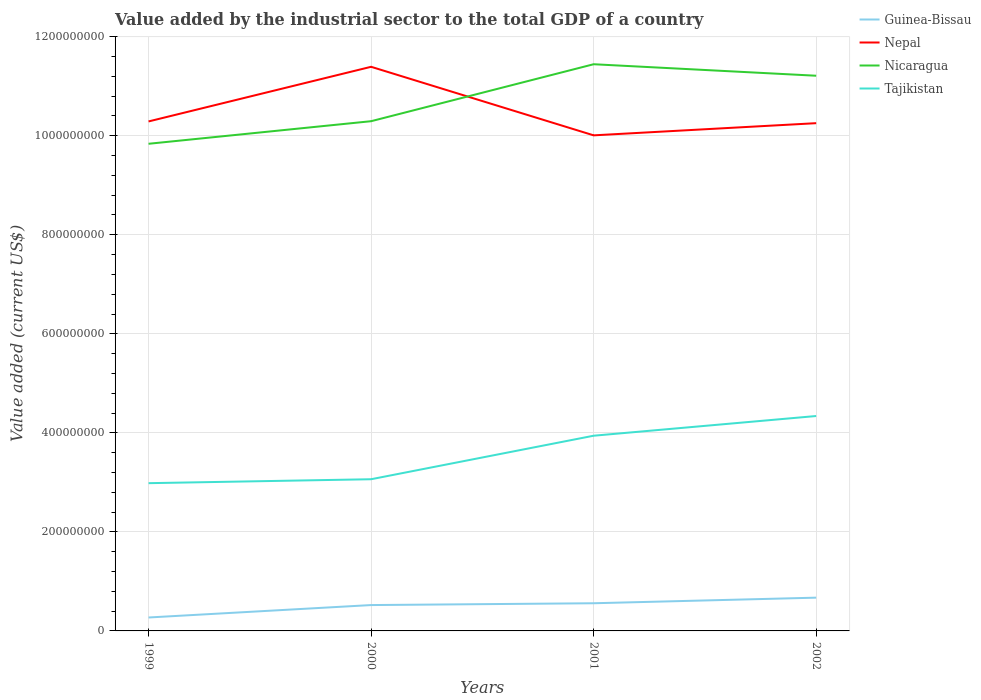How many different coloured lines are there?
Your response must be concise. 4. Does the line corresponding to Nepal intersect with the line corresponding to Nicaragua?
Offer a very short reply. Yes. Is the number of lines equal to the number of legend labels?
Provide a short and direct response. Yes. Across all years, what is the maximum value added by the industrial sector to the total GDP in Nicaragua?
Offer a terse response. 9.84e+08. In which year was the value added by the industrial sector to the total GDP in Tajikistan maximum?
Offer a terse response. 1999. What is the total value added by the industrial sector to the total GDP in Tajikistan in the graph?
Your response must be concise. -3.98e+07. What is the difference between the highest and the second highest value added by the industrial sector to the total GDP in Nepal?
Offer a terse response. 1.38e+08. What is the difference between the highest and the lowest value added by the industrial sector to the total GDP in Nicaragua?
Your answer should be very brief. 2. Is the value added by the industrial sector to the total GDP in Tajikistan strictly greater than the value added by the industrial sector to the total GDP in Nicaragua over the years?
Ensure brevity in your answer.  Yes. How many lines are there?
Keep it short and to the point. 4. How many years are there in the graph?
Offer a terse response. 4. Are the values on the major ticks of Y-axis written in scientific E-notation?
Give a very brief answer. No. Does the graph contain grids?
Offer a terse response. Yes. How many legend labels are there?
Provide a short and direct response. 4. What is the title of the graph?
Your response must be concise. Value added by the industrial sector to the total GDP of a country. What is the label or title of the Y-axis?
Your answer should be very brief. Value added (current US$). What is the Value added (current US$) of Guinea-Bissau in 1999?
Ensure brevity in your answer.  2.71e+07. What is the Value added (current US$) of Nepal in 1999?
Make the answer very short. 1.03e+09. What is the Value added (current US$) in Nicaragua in 1999?
Offer a very short reply. 9.84e+08. What is the Value added (current US$) in Tajikistan in 1999?
Make the answer very short. 2.98e+08. What is the Value added (current US$) of Guinea-Bissau in 2000?
Provide a short and direct response. 5.22e+07. What is the Value added (current US$) in Nepal in 2000?
Offer a very short reply. 1.14e+09. What is the Value added (current US$) of Nicaragua in 2000?
Your answer should be very brief. 1.03e+09. What is the Value added (current US$) in Tajikistan in 2000?
Offer a terse response. 3.06e+08. What is the Value added (current US$) of Guinea-Bissau in 2001?
Offer a very short reply. 5.59e+07. What is the Value added (current US$) in Nepal in 2001?
Give a very brief answer. 1.00e+09. What is the Value added (current US$) of Nicaragua in 2001?
Ensure brevity in your answer.  1.14e+09. What is the Value added (current US$) of Tajikistan in 2001?
Keep it short and to the point. 3.94e+08. What is the Value added (current US$) of Guinea-Bissau in 2002?
Your response must be concise. 6.72e+07. What is the Value added (current US$) of Nepal in 2002?
Provide a short and direct response. 1.03e+09. What is the Value added (current US$) in Nicaragua in 2002?
Make the answer very short. 1.12e+09. What is the Value added (current US$) in Tajikistan in 2002?
Offer a very short reply. 4.34e+08. Across all years, what is the maximum Value added (current US$) in Guinea-Bissau?
Keep it short and to the point. 6.72e+07. Across all years, what is the maximum Value added (current US$) of Nepal?
Give a very brief answer. 1.14e+09. Across all years, what is the maximum Value added (current US$) in Nicaragua?
Make the answer very short. 1.14e+09. Across all years, what is the maximum Value added (current US$) of Tajikistan?
Offer a terse response. 4.34e+08. Across all years, what is the minimum Value added (current US$) in Guinea-Bissau?
Your answer should be compact. 2.71e+07. Across all years, what is the minimum Value added (current US$) in Nepal?
Make the answer very short. 1.00e+09. Across all years, what is the minimum Value added (current US$) in Nicaragua?
Offer a terse response. 9.84e+08. Across all years, what is the minimum Value added (current US$) in Tajikistan?
Give a very brief answer. 2.98e+08. What is the total Value added (current US$) of Guinea-Bissau in the graph?
Your answer should be compact. 2.02e+08. What is the total Value added (current US$) of Nepal in the graph?
Your answer should be compact. 4.19e+09. What is the total Value added (current US$) in Nicaragua in the graph?
Offer a very short reply. 4.28e+09. What is the total Value added (current US$) in Tajikistan in the graph?
Your answer should be compact. 1.43e+09. What is the difference between the Value added (current US$) of Guinea-Bissau in 1999 and that in 2000?
Offer a very short reply. -2.51e+07. What is the difference between the Value added (current US$) in Nepal in 1999 and that in 2000?
Provide a succinct answer. -1.10e+08. What is the difference between the Value added (current US$) of Nicaragua in 1999 and that in 2000?
Offer a terse response. -4.56e+07. What is the difference between the Value added (current US$) in Tajikistan in 1999 and that in 2000?
Offer a terse response. -7.97e+06. What is the difference between the Value added (current US$) of Guinea-Bissau in 1999 and that in 2001?
Keep it short and to the point. -2.88e+07. What is the difference between the Value added (current US$) in Nepal in 1999 and that in 2001?
Ensure brevity in your answer.  2.81e+07. What is the difference between the Value added (current US$) of Nicaragua in 1999 and that in 2001?
Keep it short and to the point. -1.61e+08. What is the difference between the Value added (current US$) of Tajikistan in 1999 and that in 2001?
Keep it short and to the point. -9.58e+07. What is the difference between the Value added (current US$) of Guinea-Bissau in 1999 and that in 2002?
Your answer should be very brief. -4.01e+07. What is the difference between the Value added (current US$) in Nepal in 1999 and that in 2002?
Provide a succinct answer. 3.50e+06. What is the difference between the Value added (current US$) in Nicaragua in 1999 and that in 2002?
Make the answer very short. -1.37e+08. What is the difference between the Value added (current US$) of Tajikistan in 1999 and that in 2002?
Keep it short and to the point. -1.36e+08. What is the difference between the Value added (current US$) in Guinea-Bissau in 2000 and that in 2001?
Provide a short and direct response. -3.66e+06. What is the difference between the Value added (current US$) of Nepal in 2000 and that in 2001?
Offer a very short reply. 1.38e+08. What is the difference between the Value added (current US$) of Nicaragua in 2000 and that in 2001?
Provide a short and direct response. -1.15e+08. What is the difference between the Value added (current US$) of Tajikistan in 2000 and that in 2001?
Your answer should be compact. -8.79e+07. What is the difference between the Value added (current US$) of Guinea-Bissau in 2000 and that in 2002?
Provide a succinct answer. -1.50e+07. What is the difference between the Value added (current US$) of Nepal in 2000 and that in 2002?
Your answer should be very brief. 1.14e+08. What is the difference between the Value added (current US$) of Nicaragua in 2000 and that in 2002?
Offer a terse response. -9.18e+07. What is the difference between the Value added (current US$) in Tajikistan in 2000 and that in 2002?
Keep it short and to the point. -1.28e+08. What is the difference between the Value added (current US$) of Guinea-Bissau in 2001 and that in 2002?
Ensure brevity in your answer.  -1.13e+07. What is the difference between the Value added (current US$) of Nepal in 2001 and that in 2002?
Keep it short and to the point. -2.46e+07. What is the difference between the Value added (current US$) in Nicaragua in 2001 and that in 2002?
Your answer should be very brief. 2.32e+07. What is the difference between the Value added (current US$) in Tajikistan in 2001 and that in 2002?
Provide a short and direct response. -3.98e+07. What is the difference between the Value added (current US$) of Guinea-Bissau in 1999 and the Value added (current US$) of Nepal in 2000?
Offer a very short reply. -1.11e+09. What is the difference between the Value added (current US$) in Guinea-Bissau in 1999 and the Value added (current US$) in Nicaragua in 2000?
Your answer should be compact. -1.00e+09. What is the difference between the Value added (current US$) in Guinea-Bissau in 1999 and the Value added (current US$) in Tajikistan in 2000?
Offer a very short reply. -2.79e+08. What is the difference between the Value added (current US$) in Nepal in 1999 and the Value added (current US$) in Nicaragua in 2000?
Give a very brief answer. -4.66e+05. What is the difference between the Value added (current US$) in Nepal in 1999 and the Value added (current US$) in Tajikistan in 2000?
Your answer should be compact. 7.23e+08. What is the difference between the Value added (current US$) of Nicaragua in 1999 and the Value added (current US$) of Tajikistan in 2000?
Keep it short and to the point. 6.77e+08. What is the difference between the Value added (current US$) of Guinea-Bissau in 1999 and the Value added (current US$) of Nepal in 2001?
Give a very brief answer. -9.74e+08. What is the difference between the Value added (current US$) in Guinea-Bissau in 1999 and the Value added (current US$) in Nicaragua in 2001?
Ensure brevity in your answer.  -1.12e+09. What is the difference between the Value added (current US$) of Guinea-Bissau in 1999 and the Value added (current US$) of Tajikistan in 2001?
Your response must be concise. -3.67e+08. What is the difference between the Value added (current US$) of Nepal in 1999 and the Value added (current US$) of Nicaragua in 2001?
Give a very brief answer. -1.16e+08. What is the difference between the Value added (current US$) in Nepal in 1999 and the Value added (current US$) in Tajikistan in 2001?
Your answer should be very brief. 6.35e+08. What is the difference between the Value added (current US$) of Nicaragua in 1999 and the Value added (current US$) of Tajikistan in 2001?
Ensure brevity in your answer.  5.90e+08. What is the difference between the Value added (current US$) of Guinea-Bissau in 1999 and the Value added (current US$) of Nepal in 2002?
Offer a terse response. -9.98e+08. What is the difference between the Value added (current US$) of Guinea-Bissau in 1999 and the Value added (current US$) of Nicaragua in 2002?
Keep it short and to the point. -1.09e+09. What is the difference between the Value added (current US$) in Guinea-Bissau in 1999 and the Value added (current US$) in Tajikistan in 2002?
Your answer should be compact. -4.07e+08. What is the difference between the Value added (current US$) of Nepal in 1999 and the Value added (current US$) of Nicaragua in 2002?
Give a very brief answer. -9.23e+07. What is the difference between the Value added (current US$) of Nepal in 1999 and the Value added (current US$) of Tajikistan in 2002?
Your answer should be very brief. 5.95e+08. What is the difference between the Value added (current US$) of Nicaragua in 1999 and the Value added (current US$) of Tajikistan in 2002?
Offer a terse response. 5.50e+08. What is the difference between the Value added (current US$) of Guinea-Bissau in 2000 and the Value added (current US$) of Nepal in 2001?
Offer a terse response. -9.49e+08. What is the difference between the Value added (current US$) of Guinea-Bissau in 2000 and the Value added (current US$) of Nicaragua in 2001?
Your response must be concise. -1.09e+09. What is the difference between the Value added (current US$) in Guinea-Bissau in 2000 and the Value added (current US$) in Tajikistan in 2001?
Make the answer very short. -3.42e+08. What is the difference between the Value added (current US$) in Nepal in 2000 and the Value added (current US$) in Nicaragua in 2001?
Keep it short and to the point. -5.18e+06. What is the difference between the Value added (current US$) of Nepal in 2000 and the Value added (current US$) of Tajikistan in 2001?
Ensure brevity in your answer.  7.45e+08. What is the difference between the Value added (current US$) in Nicaragua in 2000 and the Value added (current US$) in Tajikistan in 2001?
Your answer should be very brief. 6.35e+08. What is the difference between the Value added (current US$) of Guinea-Bissau in 2000 and the Value added (current US$) of Nepal in 2002?
Keep it short and to the point. -9.73e+08. What is the difference between the Value added (current US$) of Guinea-Bissau in 2000 and the Value added (current US$) of Nicaragua in 2002?
Your answer should be very brief. -1.07e+09. What is the difference between the Value added (current US$) of Guinea-Bissau in 2000 and the Value added (current US$) of Tajikistan in 2002?
Keep it short and to the point. -3.82e+08. What is the difference between the Value added (current US$) in Nepal in 2000 and the Value added (current US$) in Nicaragua in 2002?
Keep it short and to the point. 1.80e+07. What is the difference between the Value added (current US$) in Nepal in 2000 and the Value added (current US$) in Tajikistan in 2002?
Provide a short and direct response. 7.05e+08. What is the difference between the Value added (current US$) of Nicaragua in 2000 and the Value added (current US$) of Tajikistan in 2002?
Your answer should be compact. 5.95e+08. What is the difference between the Value added (current US$) of Guinea-Bissau in 2001 and the Value added (current US$) of Nepal in 2002?
Offer a terse response. -9.70e+08. What is the difference between the Value added (current US$) of Guinea-Bissau in 2001 and the Value added (current US$) of Nicaragua in 2002?
Give a very brief answer. -1.07e+09. What is the difference between the Value added (current US$) of Guinea-Bissau in 2001 and the Value added (current US$) of Tajikistan in 2002?
Provide a short and direct response. -3.78e+08. What is the difference between the Value added (current US$) in Nepal in 2001 and the Value added (current US$) in Nicaragua in 2002?
Give a very brief answer. -1.20e+08. What is the difference between the Value added (current US$) in Nepal in 2001 and the Value added (current US$) in Tajikistan in 2002?
Provide a short and direct response. 5.67e+08. What is the difference between the Value added (current US$) in Nicaragua in 2001 and the Value added (current US$) in Tajikistan in 2002?
Offer a terse response. 7.10e+08. What is the average Value added (current US$) of Guinea-Bissau per year?
Provide a short and direct response. 5.06e+07. What is the average Value added (current US$) in Nepal per year?
Make the answer very short. 1.05e+09. What is the average Value added (current US$) of Nicaragua per year?
Your answer should be very brief. 1.07e+09. What is the average Value added (current US$) of Tajikistan per year?
Make the answer very short. 3.58e+08. In the year 1999, what is the difference between the Value added (current US$) in Guinea-Bissau and Value added (current US$) in Nepal?
Ensure brevity in your answer.  -1.00e+09. In the year 1999, what is the difference between the Value added (current US$) in Guinea-Bissau and Value added (current US$) in Nicaragua?
Offer a terse response. -9.57e+08. In the year 1999, what is the difference between the Value added (current US$) in Guinea-Bissau and Value added (current US$) in Tajikistan?
Provide a short and direct response. -2.71e+08. In the year 1999, what is the difference between the Value added (current US$) in Nepal and Value added (current US$) in Nicaragua?
Provide a short and direct response. 4.51e+07. In the year 1999, what is the difference between the Value added (current US$) in Nepal and Value added (current US$) in Tajikistan?
Give a very brief answer. 7.31e+08. In the year 1999, what is the difference between the Value added (current US$) of Nicaragua and Value added (current US$) of Tajikistan?
Provide a succinct answer. 6.85e+08. In the year 2000, what is the difference between the Value added (current US$) of Guinea-Bissau and Value added (current US$) of Nepal?
Offer a very short reply. -1.09e+09. In the year 2000, what is the difference between the Value added (current US$) of Guinea-Bissau and Value added (current US$) of Nicaragua?
Your answer should be very brief. -9.77e+08. In the year 2000, what is the difference between the Value added (current US$) in Guinea-Bissau and Value added (current US$) in Tajikistan?
Offer a very short reply. -2.54e+08. In the year 2000, what is the difference between the Value added (current US$) in Nepal and Value added (current US$) in Nicaragua?
Give a very brief answer. 1.10e+08. In the year 2000, what is the difference between the Value added (current US$) of Nepal and Value added (current US$) of Tajikistan?
Provide a short and direct response. 8.33e+08. In the year 2000, what is the difference between the Value added (current US$) of Nicaragua and Value added (current US$) of Tajikistan?
Keep it short and to the point. 7.23e+08. In the year 2001, what is the difference between the Value added (current US$) in Guinea-Bissau and Value added (current US$) in Nepal?
Provide a short and direct response. -9.45e+08. In the year 2001, what is the difference between the Value added (current US$) in Guinea-Bissau and Value added (current US$) in Nicaragua?
Provide a short and direct response. -1.09e+09. In the year 2001, what is the difference between the Value added (current US$) of Guinea-Bissau and Value added (current US$) of Tajikistan?
Keep it short and to the point. -3.38e+08. In the year 2001, what is the difference between the Value added (current US$) in Nepal and Value added (current US$) in Nicaragua?
Make the answer very short. -1.44e+08. In the year 2001, what is the difference between the Value added (current US$) in Nepal and Value added (current US$) in Tajikistan?
Give a very brief answer. 6.07e+08. In the year 2001, what is the difference between the Value added (current US$) of Nicaragua and Value added (current US$) of Tajikistan?
Ensure brevity in your answer.  7.50e+08. In the year 2002, what is the difference between the Value added (current US$) in Guinea-Bissau and Value added (current US$) in Nepal?
Offer a very short reply. -9.58e+08. In the year 2002, what is the difference between the Value added (current US$) in Guinea-Bissau and Value added (current US$) in Nicaragua?
Give a very brief answer. -1.05e+09. In the year 2002, what is the difference between the Value added (current US$) of Guinea-Bissau and Value added (current US$) of Tajikistan?
Offer a very short reply. -3.67e+08. In the year 2002, what is the difference between the Value added (current US$) of Nepal and Value added (current US$) of Nicaragua?
Ensure brevity in your answer.  -9.58e+07. In the year 2002, what is the difference between the Value added (current US$) in Nepal and Value added (current US$) in Tajikistan?
Make the answer very short. 5.91e+08. In the year 2002, what is the difference between the Value added (current US$) in Nicaragua and Value added (current US$) in Tajikistan?
Your response must be concise. 6.87e+08. What is the ratio of the Value added (current US$) of Guinea-Bissau in 1999 to that in 2000?
Your answer should be compact. 0.52. What is the ratio of the Value added (current US$) in Nepal in 1999 to that in 2000?
Your answer should be compact. 0.9. What is the ratio of the Value added (current US$) of Nicaragua in 1999 to that in 2000?
Offer a very short reply. 0.96. What is the ratio of the Value added (current US$) of Tajikistan in 1999 to that in 2000?
Your response must be concise. 0.97. What is the ratio of the Value added (current US$) in Guinea-Bissau in 1999 to that in 2001?
Keep it short and to the point. 0.49. What is the ratio of the Value added (current US$) in Nepal in 1999 to that in 2001?
Offer a very short reply. 1.03. What is the ratio of the Value added (current US$) in Nicaragua in 1999 to that in 2001?
Make the answer very short. 0.86. What is the ratio of the Value added (current US$) in Tajikistan in 1999 to that in 2001?
Ensure brevity in your answer.  0.76. What is the ratio of the Value added (current US$) of Guinea-Bissau in 1999 to that in 2002?
Make the answer very short. 0.4. What is the ratio of the Value added (current US$) in Nepal in 1999 to that in 2002?
Your answer should be very brief. 1. What is the ratio of the Value added (current US$) of Nicaragua in 1999 to that in 2002?
Provide a succinct answer. 0.88. What is the ratio of the Value added (current US$) in Tajikistan in 1999 to that in 2002?
Your answer should be very brief. 0.69. What is the ratio of the Value added (current US$) in Guinea-Bissau in 2000 to that in 2001?
Provide a short and direct response. 0.93. What is the ratio of the Value added (current US$) in Nepal in 2000 to that in 2001?
Your response must be concise. 1.14. What is the ratio of the Value added (current US$) in Nicaragua in 2000 to that in 2001?
Keep it short and to the point. 0.9. What is the ratio of the Value added (current US$) in Tajikistan in 2000 to that in 2001?
Offer a terse response. 0.78. What is the ratio of the Value added (current US$) of Guinea-Bissau in 2000 to that in 2002?
Make the answer very short. 0.78. What is the ratio of the Value added (current US$) in Nepal in 2000 to that in 2002?
Your response must be concise. 1.11. What is the ratio of the Value added (current US$) of Nicaragua in 2000 to that in 2002?
Keep it short and to the point. 0.92. What is the ratio of the Value added (current US$) of Tajikistan in 2000 to that in 2002?
Your answer should be compact. 0.71. What is the ratio of the Value added (current US$) of Guinea-Bissau in 2001 to that in 2002?
Give a very brief answer. 0.83. What is the ratio of the Value added (current US$) in Nicaragua in 2001 to that in 2002?
Provide a succinct answer. 1.02. What is the ratio of the Value added (current US$) in Tajikistan in 2001 to that in 2002?
Ensure brevity in your answer.  0.91. What is the difference between the highest and the second highest Value added (current US$) of Guinea-Bissau?
Offer a very short reply. 1.13e+07. What is the difference between the highest and the second highest Value added (current US$) in Nepal?
Provide a short and direct response. 1.10e+08. What is the difference between the highest and the second highest Value added (current US$) of Nicaragua?
Your answer should be compact. 2.32e+07. What is the difference between the highest and the second highest Value added (current US$) in Tajikistan?
Your response must be concise. 3.98e+07. What is the difference between the highest and the lowest Value added (current US$) of Guinea-Bissau?
Keep it short and to the point. 4.01e+07. What is the difference between the highest and the lowest Value added (current US$) in Nepal?
Provide a short and direct response. 1.38e+08. What is the difference between the highest and the lowest Value added (current US$) of Nicaragua?
Offer a very short reply. 1.61e+08. What is the difference between the highest and the lowest Value added (current US$) of Tajikistan?
Your response must be concise. 1.36e+08. 